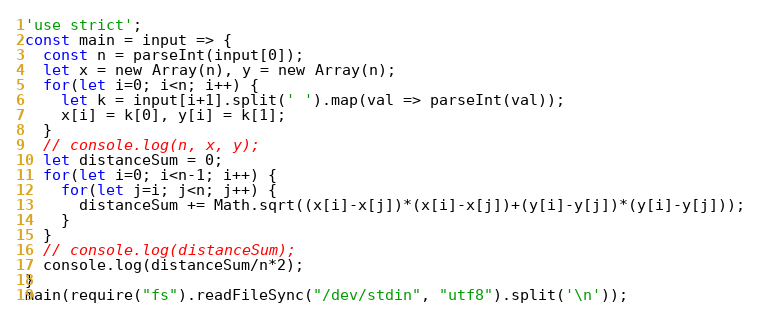Convert code to text. <code><loc_0><loc_0><loc_500><loc_500><_JavaScript_>'use strict';
const main = input => {
  const n = parseInt(input[0]);
  let x = new Array(n), y = new Array(n);
  for(let i=0; i<n; i++) {
    let k = input[i+1].split(' ').map(val => parseInt(val));
    x[i] = k[0], y[i] = k[1];
  }
  // console.log(n, x, y);
  let distanceSum = 0;
  for(let i=0; i<n-1; i++) {
    for(let j=i; j<n; j++) {
      distanceSum += Math.sqrt((x[i]-x[j])*(x[i]-x[j])+(y[i]-y[j])*(y[i]-y[j]));
    }
  }
  // console.log(distanceSum);
  console.log(distanceSum/n*2);
}
main(require("fs").readFileSync("/dev/stdin", "utf8").split('\n'));</code> 